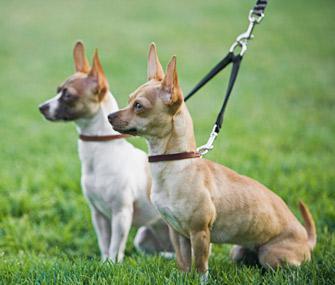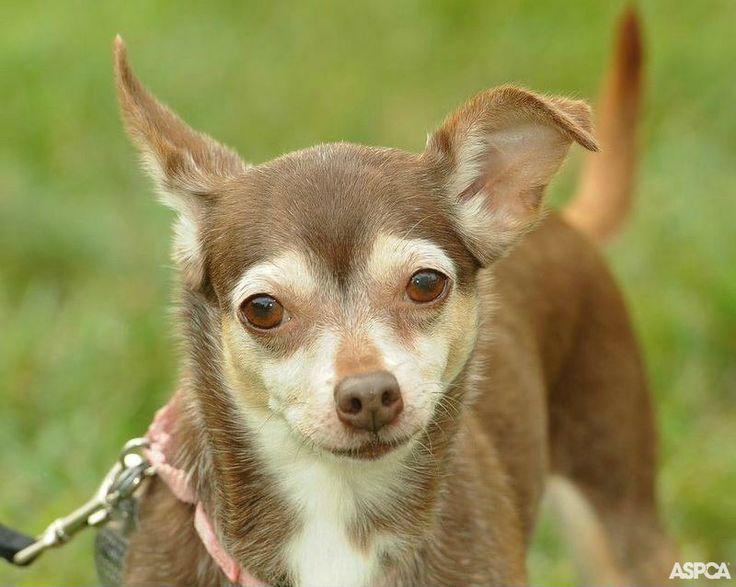The first image is the image on the left, the second image is the image on the right. Assess this claim about the two images: "Left image features two small dogs with no collars or leashes.". Correct or not? Answer yes or no. No. The first image is the image on the left, the second image is the image on the right. Assess this claim about the two images: "One dog's tail is fluffy.". Correct or not? Answer yes or no. No. 